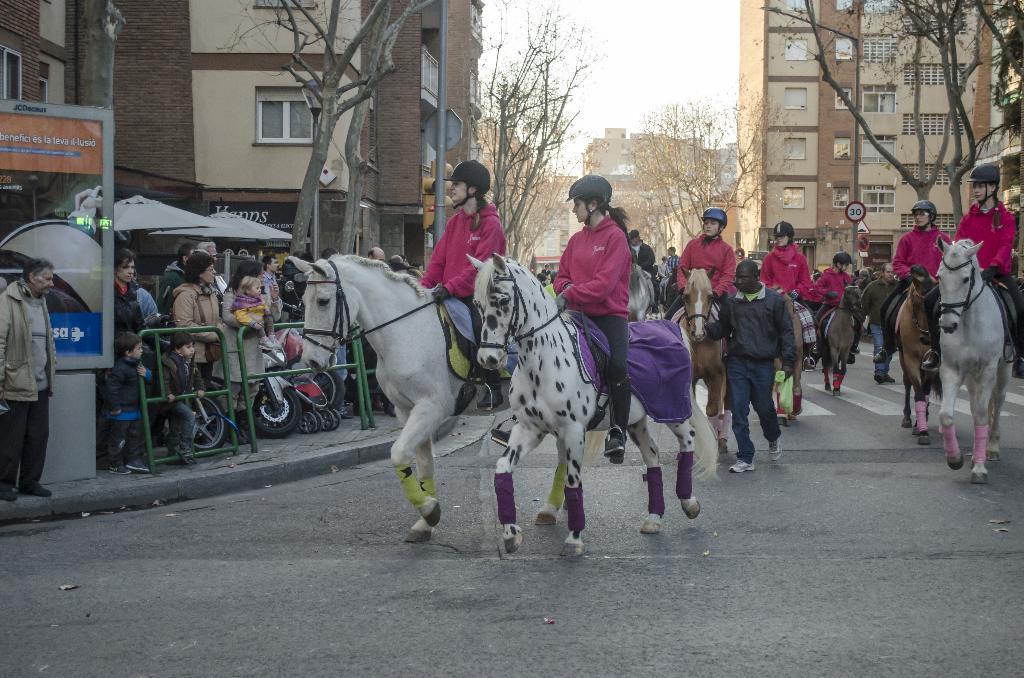Please provide a concise description of this image. This picture describes about group of people, few are standing, few are seated on the horses, and few people wore helmets, beside to them we can find few vehicles and metal rods, in the background we can see few buildings, trees, poles, sign boards and umbrellas. 